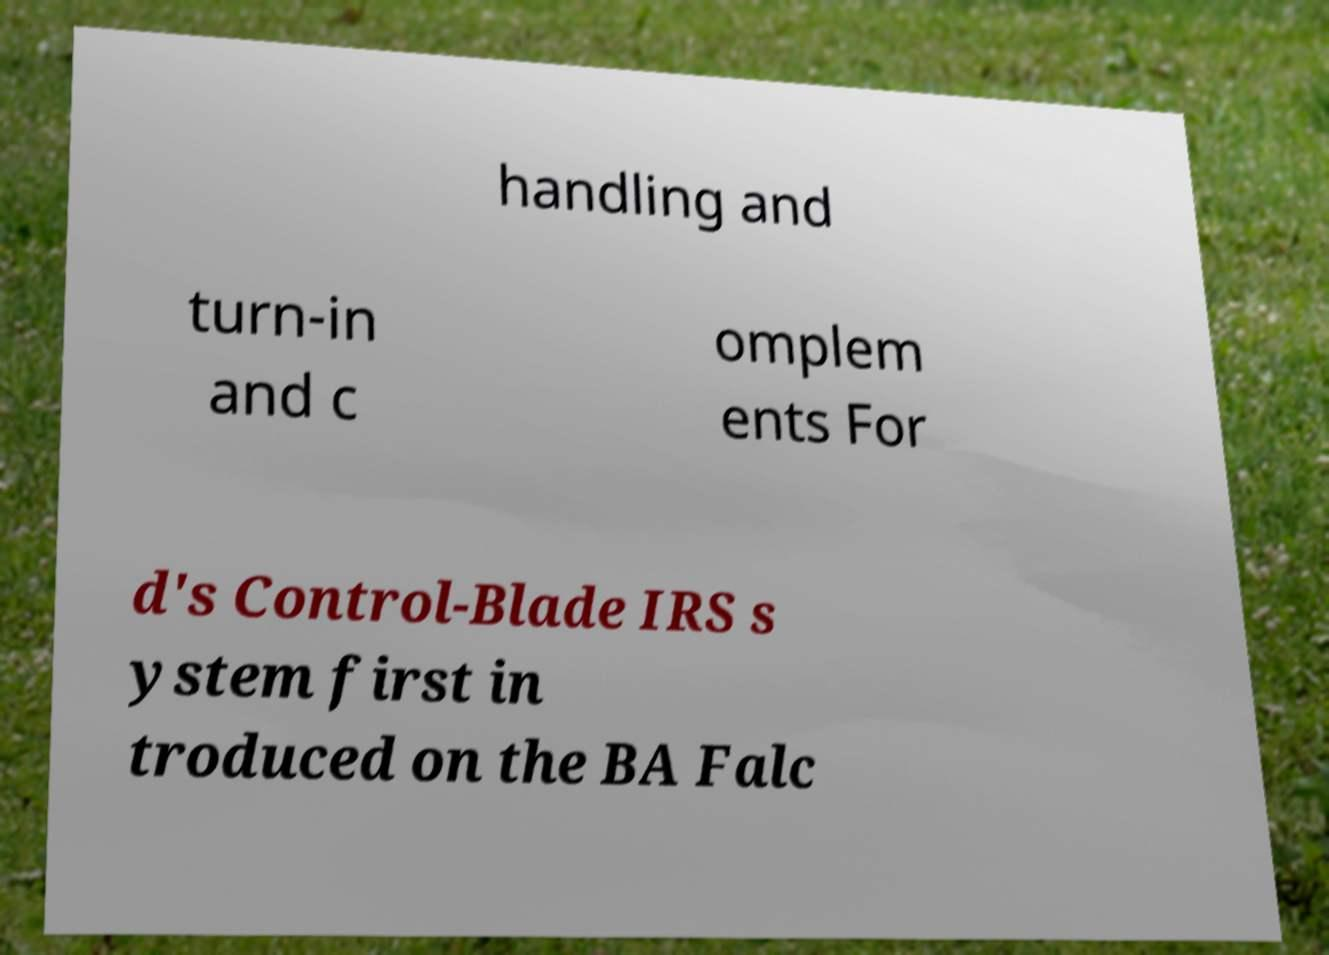What messages or text are displayed in this image? I need them in a readable, typed format. handling and turn-in and c omplem ents For d's Control-Blade IRS s ystem first in troduced on the BA Falc 